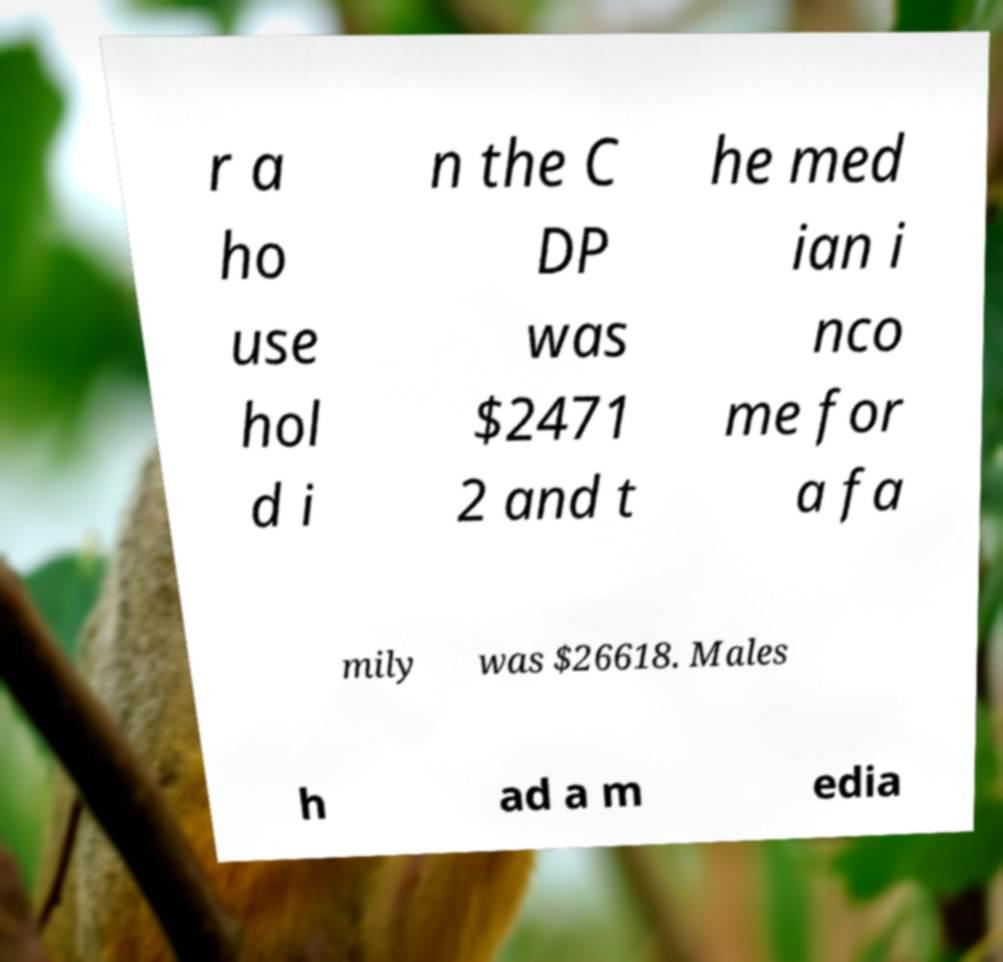I need the written content from this picture converted into text. Can you do that? r a ho use hol d i n the C DP was $2471 2 and t he med ian i nco me for a fa mily was $26618. Males h ad a m edia 